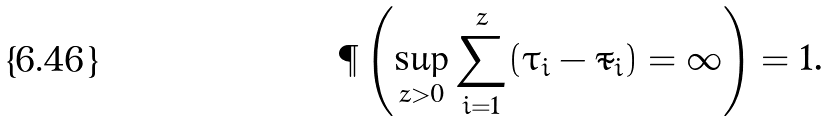<formula> <loc_0><loc_0><loc_500><loc_500>\P \left ( \sup _ { z > 0 } \sum _ { i = 1 } ^ { z } ( \tau _ { i } - \tilde { \tau } _ { i } ) = \infty \right ) = 1 .</formula> 